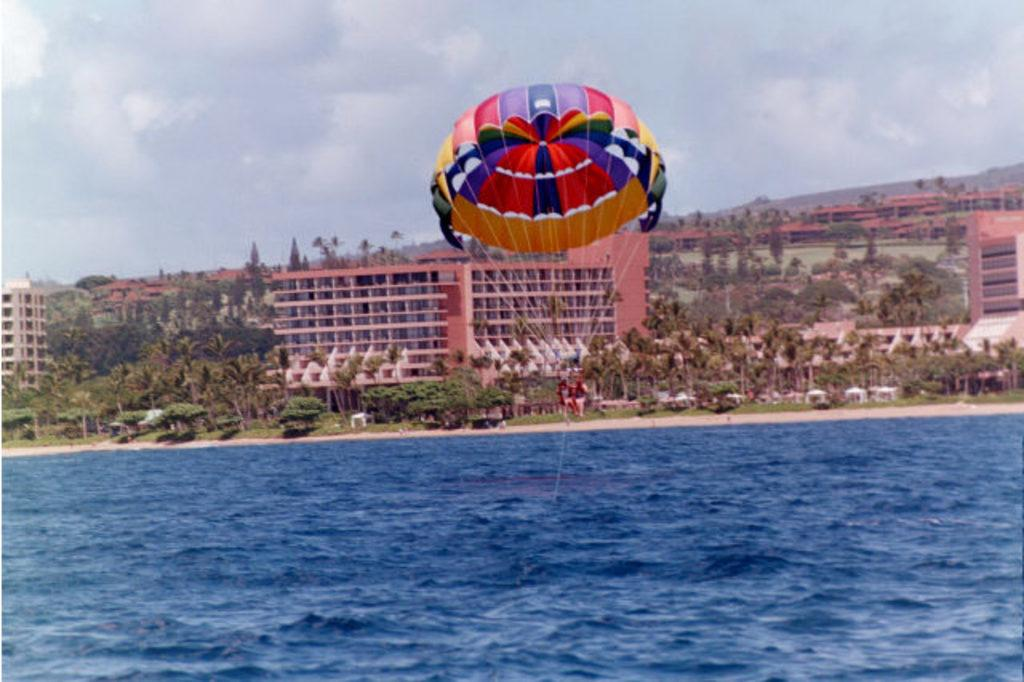How many people are in the image? There are two persons in the image. What are the persons tied to in the image? The persons are tied to a parachute. What is at the bottom of the image? There is water at the bottom of the image. What type of vegetation can be seen in the image? There are trees in the image. What type of structures are visible on the land? There are buildings on the land. What is visible at the top of the image? The sky is visible at the top of the image. What type of tank can be seen in the image? There is no tank present in the image. How many divisions are visible in the image? There are no divisions present in the image. 